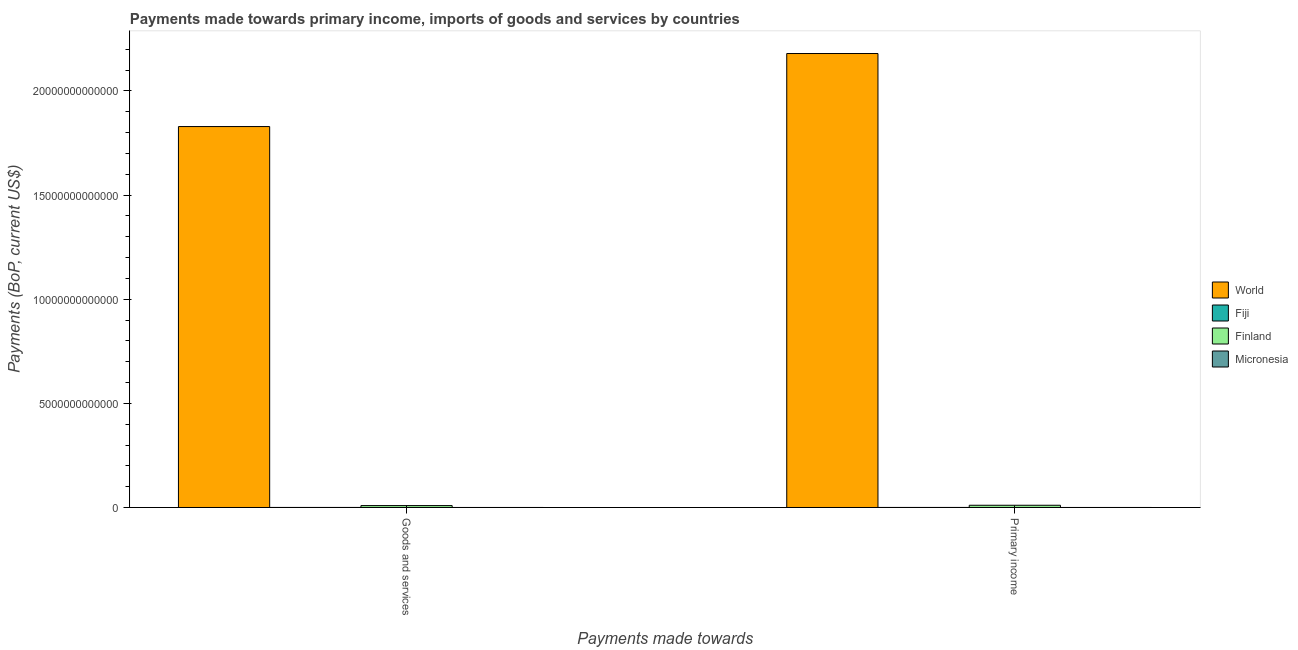How many groups of bars are there?
Provide a short and direct response. 2. Are the number of bars on each tick of the X-axis equal?
Offer a very short reply. Yes. How many bars are there on the 1st tick from the left?
Offer a very short reply. 4. How many bars are there on the 2nd tick from the right?
Ensure brevity in your answer.  4. What is the label of the 2nd group of bars from the left?
Offer a very short reply. Primary income. What is the payments made towards primary income in World?
Your answer should be compact. 2.18e+13. Across all countries, what is the maximum payments made towards primary income?
Give a very brief answer. 2.18e+13. Across all countries, what is the minimum payments made towards goods and services?
Provide a short and direct response. 2.39e+08. In which country was the payments made towards primary income minimum?
Your answer should be compact. Micronesia. What is the total payments made towards goods and services in the graph?
Keep it short and to the point. 1.84e+13. What is the difference between the payments made towards goods and services in Fiji and that in Finland?
Offer a terse response. -8.92e+1. What is the difference between the payments made towards goods and services in Fiji and the payments made towards primary income in World?
Make the answer very short. -2.18e+13. What is the average payments made towards goods and services per country?
Give a very brief answer. 4.60e+12. What is the difference between the payments made towards goods and services and payments made towards primary income in Fiji?
Ensure brevity in your answer.  -1.79e+08. In how many countries, is the payments made towards primary income greater than 17000000000000 US$?
Offer a very short reply. 1. What is the ratio of the payments made towards primary income in Finland to that in World?
Your answer should be very brief. 0. What does the 4th bar from the left in Primary income represents?
Give a very brief answer. Micronesia. What does the 3rd bar from the right in Primary income represents?
Make the answer very short. Fiji. Are all the bars in the graph horizontal?
Keep it short and to the point. No. What is the difference between two consecutive major ticks on the Y-axis?
Your answer should be very brief. 5.00e+12. Are the values on the major ticks of Y-axis written in scientific E-notation?
Offer a very short reply. No. Does the graph contain any zero values?
Offer a very short reply. No. Where does the legend appear in the graph?
Provide a succinct answer. Center right. What is the title of the graph?
Provide a succinct answer. Payments made towards primary income, imports of goods and services by countries. Does "Georgia" appear as one of the legend labels in the graph?
Your answer should be very brief. No. What is the label or title of the X-axis?
Offer a terse response. Payments made towards. What is the label or title of the Y-axis?
Give a very brief answer. Payments (BoP, current US$). What is the Payments (BoP, current US$) in World in Goods and services?
Offer a terse response. 1.83e+13. What is the Payments (BoP, current US$) of Fiji in Goods and services?
Provide a succinct answer. 2.01e+09. What is the Payments (BoP, current US$) of Finland in Goods and services?
Offer a terse response. 9.12e+1. What is the Payments (BoP, current US$) in Micronesia in Goods and services?
Keep it short and to the point. 2.39e+08. What is the Payments (BoP, current US$) in World in Primary income?
Make the answer very short. 2.18e+13. What is the Payments (BoP, current US$) of Fiji in Primary income?
Make the answer very short. 2.19e+09. What is the Payments (BoP, current US$) of Finland in Primary income?
Your answer should be very brief. 1.07e+11. What is the Payments (BoP, current US$) of Micronesia in Primary income?
Provide a succinct answer. 2.51e+08. Across all Payments made towards, what is the maximum Payments (BoP, current US$) of World?
Provide a succinct answer. 2.18e+13. Across all Payments made towards, what is the maximum Payments (BoP, current US$) of Fiji?
Provide a short and direct response. 2.19e+09. Across all Payments made towards, what is the maximum Payments (BoP, current US$) of Finland?
Offer a very short reply. 1.07e+11. Across all Payments made towards, what is the maximum Payments (BoP, current US$) in Micronesia?
Offer a very short reply. 2.51e+08. Across all Payments made towards, what is the minimum Payments (BoP, current US$) in World?
Give a very brief answer. 1.83e+13. Across all Payments made towards, what is the minimum Payments (BoP, current US$) of Fiji?
Provide a short and direct response. 2.01e+09. Across all Payments made towards, what is the minimum Payments (BoP, current US$) of Finland?
Make the answer very short. 9.12e+1. Across all Payments made towards, what is the minimum Payments (BoP, current US$) of Micronesia?
Your answer should be compact. 2.39e+08. What is the total Payments (BoP, current US$) of World in the graph?
Your response must be concise. 4.01e+13. What is the total Payments (BoP, current US$) of Fiji in the graph?
Your answer should be very brief. 4.20e+09. What is the total Payments (BoP, current US$) in Finland in the graph?
Offer a terse response. 1.98e+11. What is the total Payments (BoP, current US$) of Micronesia in the graph?
Offer a terse response. 4.90e+08. What is the difference between the Payments (BoP, current US$) in World in Goods and services and that in Primary income?
Ensure brevity in your answer.  -3.51e+12. What is the difference between the Payments (BoP, current US$) of Fiji in Goods and services and that in Primary income?
Your response must be concise. -1.79e+08. What is the difference between the Payments (BoP, current US$) in Finland in Goods and services and that in Primary income?
Keep it short and to the point. -1.56e+1. What is the difference between the Payments (BoP, current US$) of Micronesia in Goods and services and that in Primary income?
Ensure brevity in your answer.  -1.25e+07. What is the difference between the Payments (BoP, current US$) in World in Goods and services and the Payments (BoP, current US$) in Fiji in Primary income?
Your answer should be very brief. 1.83e+13. What is the difference between the Payments (BoP, current US$) in World in Goods and services and the Payments (BoP, current US$) in Finland in Primary income?
Make the answer very short. 1.82e+13. What is the difference between the Payments (BoP, current US$) in World in Goods and services and the Payments (BoP, current US$) in Micronesia in Primary income?
Provide a succinct answer. 1.83e+13. What is the difference between the Payments (BoP, current US$) of Fiji in Goods and services and the Payments (BoP, current US$) of Finland in Primary income?
Ensure brevity in your answer.  -1.05e+11. What is the difference between the Payments (BoP, current US$) in Fiji in Goods and services and the Payments (BoP, current US$) in Micronesia in Primary income?
Ensure brevity in your answer.  1.76e+09. What is the difference between the Payments (BoP, current US$) in Finland in Goods and services and the Payments (BoP, current US$) in Micronesia in Primary income?
Give a very brief answer. 9.09e+1. What is the average Payments (BoP, current US$) in World per Payments made towards?
Ensure brevity in your answer.  2.00e+13. What is the average Payments (BoP, current US$) in Fiji per Payments made towards?
Provide a succinct answer. 2.10e+09. What is the average Payments (BoP, current US$) in Finland per Payments made towards?
Make the answer very short. 9.90e+1. What is the average Payments (BoP, current US$) in Micronesia per Payments made towards?
Your answer should be compact. 2.45e+08. What is the difference between the Payments (BoP, current US$) of World and Payments (BoP, current US$) of Fiji in Goods and services?
Keep it short and to the point. 1.83e+13. What is the difference between the Payments (BoP, current US$) in World and Payments (BoP, current US$) in Finland in Goods and services?
Provide a short and direct response. 1.82e+13. What is the difference between the Payments (BoP, current US$) in World and Payments (BoP, current US$) in Micronesia in Goods and services?
Offer a terse response. 1.83e+13. What is the difference between the Payments (BoP, current US$) in Fiji and Payments (BoP, current US$) in Finland in Goods and services?
Offer a terse response. -8.92e+1. What is the difference between the Payments (BoP, current US$) of Fiji and Payments (BoP, current US$) of Micronesia in Goods and services?
Provide a succinct answer. 1.77e+09. What is the difference between the Payments (BoP, current US$) of Finland and Payments (BoP, current US$) of Micronesia in Goods and services?
Offer a terse response. 9.10e+1. What is the difference between the Payments (BoP, current US$) in World and Payments (BoP, current US$) in Fiji in Primary income?
Ensure brevity in your answer.  2.18e+13. What is the difference between the Payments (BoP, current US$) in World and Payments (BoP, current US$) in Finland in Primary income?
Give a very brief answer. 2.17e+13. What is the difference between the Payments (BoP, current US$) of World and Payments (BoP, current US$) of Micronesia in Primary income?
Ensure brevity in your answer.  2.18e+13. What is the difference between the Payments (BoP, current US$) of Fiji and Payments (BoP, current US$) of Finland in Primary income?
Your answer should be very brief. -1.05e+11. What is the difference between the Payments (BoP, current US$) of Fiji and Payments (BoP, current US$) of Micronesia in Primary income?
Make the answer very short. 1.94e+09. What is the difference between the Payments (BoP, current US$) in Finland and Payments (BoP, current US$) in Micronesia in Primary income?
Give a very brief answer. 1.07e+11. What is the ratio of the Payments (BoP, current US$) of World in Goods and services to that in Primary income?
Your answer should be very brief. 0.84. What is the ratio of the Payments (BoP, current US$) in Fiji in Goods and services to that in Primary income?
Make the answer very short. 0.92. What is the ratio of the Payments (BoP, current US$) of Finland in Goods and services to that in Primary income?
Give a very brief answer. 0.85. What is the ratio of the Payments (BoP, current US$) in Micronesia in Goods and services to that in Primary income?
Keep it short and to the point. 0.95. What is the difference between the highest and the second highest Payments (BoP, current US$) of World?
Your answer should be compact. 3.51e+12. What is the difference between the highest and the second highest Payments (BoP, current US$) in Fiji?
Make the answer very short. 1.79e+08. What is the difference between the highest and the second highest Payments (BoP, current US$) of Finland?
Your response must be concise. 1.56e+1. What is the difference between the highest and the second highest Payments (BoP, current US$) of Micronesia?
Provide a succinct answer. 1.25e+07. What is the difference between the highest and the lowest Payments (BoP, current US$) in World?
Provide a succinct answer. 3.51e+12. What is the difference between the highest and the lowest Payments (BoP, current US$) of Fiji?
Provide a succinct answer. 1.79e+08. What is the difference between the highest and the lowest Payments (BoP, current US$) in Finland?
Provide a short and direct response. 1.56e+1. What is the difference between the highest and the lowest Payments (BoP, current US$) of Micronesia?
Your answer should be very brief. 1.25e+07. 